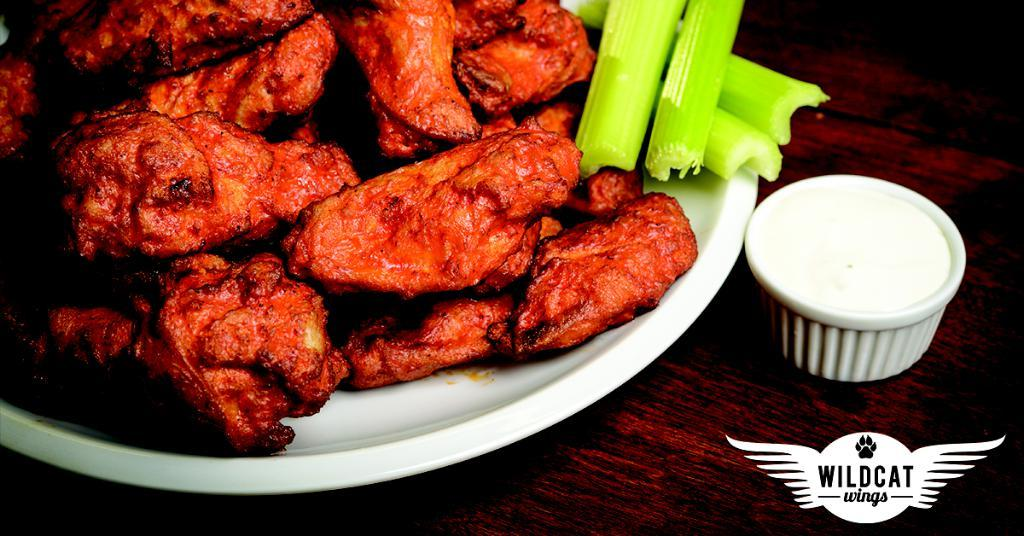What type of surface is visible in the image? There is a wooden surface in the image. What is placed on the wooden surface? There is a plate and a cup on the wooden surface. What is in the plate? There is food in the plate. Where can the logo and text be found in the image? The logo and text are located at the right bottom of the image. What type of plants are growing on the wooden surface in the image? There are no plants visible on the wooden surface in the image. What idea does the text at the right bottom of the image convey? The text at the right bottom of the image does not convey an idea, as it is not clear what the text is about without additional context. 